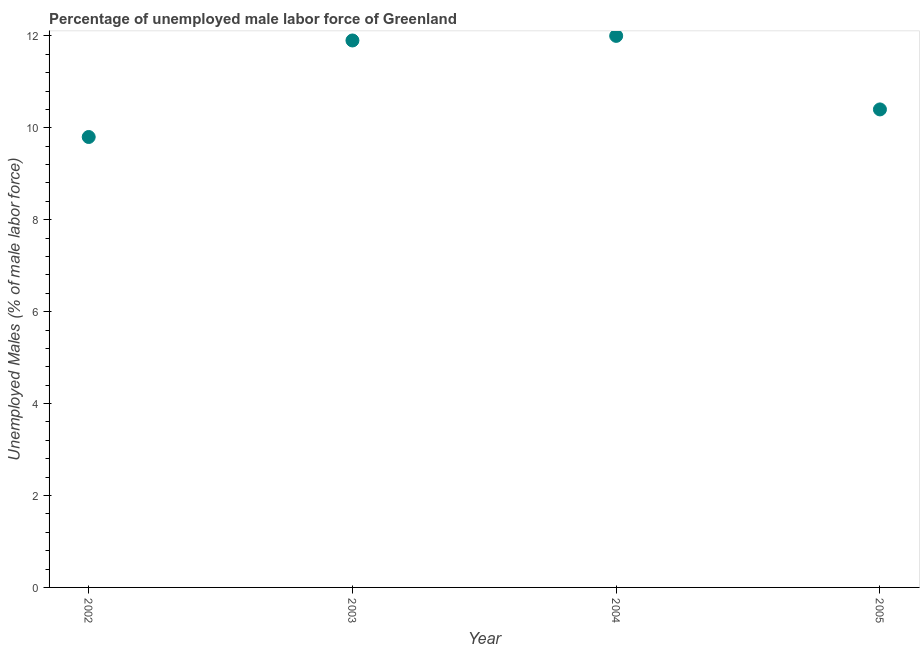What is the total unemployed male labour force in 2003?
Ensure brevity in your answer.  11.9. Across all years, what is the minimum total unemployed male labour force?
Provide a short and direct response. 9.8. In which year was the total unemployed male labour force maximum?
Provide a short and direct response. 2004. In which year was the total unemployed male labour force minimum?
Ensure brevity in your answer.  2002. What is the sum of the total unemployed male labour force?
Provide a short and direct response. 44.1. What is the difference between the total unemployed male labour force in 2004 and 2005?
Give a very brief answer. 1.6. What is the average total unemployed male labour force per year?
Your answer should be compact. 11.02. What is the median total unemployed male labour force?
Ensure brevity in your answer.  11.15. In how many years, is the total unemployed male labour force greater than 7.6 %?
Make the answer very short. 4. What is the ratio of the total unemployed male labour force in 2003 to that in 2005?
Your answer should be very brief. 1.14. Is the difference between the total unemployed male labour force in 2002 and 2005 greater than the difference between any two years?
Your answer should be very brief. No. What is the difference between the highest and the second highest total unemployed male labour force?
Your answer should be very brief. 0.1. What is the difference between the highest and the lowest total unemployed male labour force?
Your response must be concise. 2.2. In how many years, is the total unemployed male labour force greater than the average total unemployed male labour force taken over all years?
Your answer should be very brief. 2. Does the total unemployed male labour force monotonically increase over the years?
Provide a succinct answer. No. How many dotlines are there?
Offer a very short reply. 1. What is the title of the graph?
Provide a succinct answer. Percentage of unemployed male labor force of Greenland. What is the label or title of the Y-axis?
Your answer should be compact. Unemployed Males (% of male labor force). What is the Unemployed Males (% of male labor force) in 2002?
Provide a succinct answer. 9.8. What is the Unemployed Males (% of male labor force) in 2003?
Make the answer very short. 11.9. What is the Unemployed Males (% of male labor force) in 2005?
Make the answer very short. 10.4. What is the difference between the Unemployed Males (% of male labor force) in 2002 and 2003?
Keep it short and to the point. -2.1. What is the ratio of the Unemployed Males (% of male labor force) in 2002 to that in 2003?
Keep it short and to the point. 0.82. What is the ratio of the Unemployed Males (% of male labor force) in 2002 to that in 2004?
Your answer should be compact. 0.82. What is the ratio of the Unemployed Males (% of male labor force) in 2002 to that in 2005?
Offer a terse response. 0.94. What is the ratio of the Unemployed Males (% of male labor force) in 2003 to that in 2004?
Give a very brief answer. 0.99. What is the ratio of the Unemployed Males (% of male labor force) in 2003 to that in 2005?
Give a very brief answer. 1.14. What is the ratio of the Unemployed Males (% of male labor force) in 2004 to that in 2005?
Offer a very short reply. 1.15. 